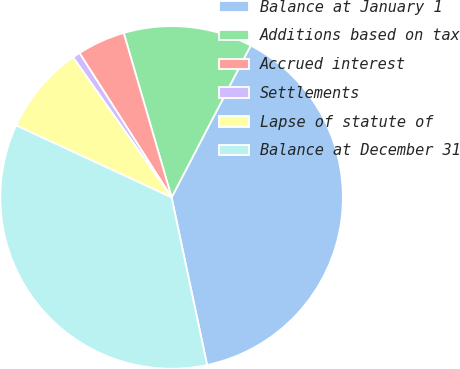Convert chart. <chart><loc_0><loc_0><loc_500><loc_500><pie_chart><fcel>Balance at January 1<fcel>Additions based on tax<fcel>Accrued interest<fcel>Settlements<fcel>Lapse of statute of<fcel>Balance at December 31<nl><fcel>39.04%<fcel>12.15%<fcel>4.53%<fcel>0.72%<fcel>8.34%<fcel>35.23%<nl></chart> 